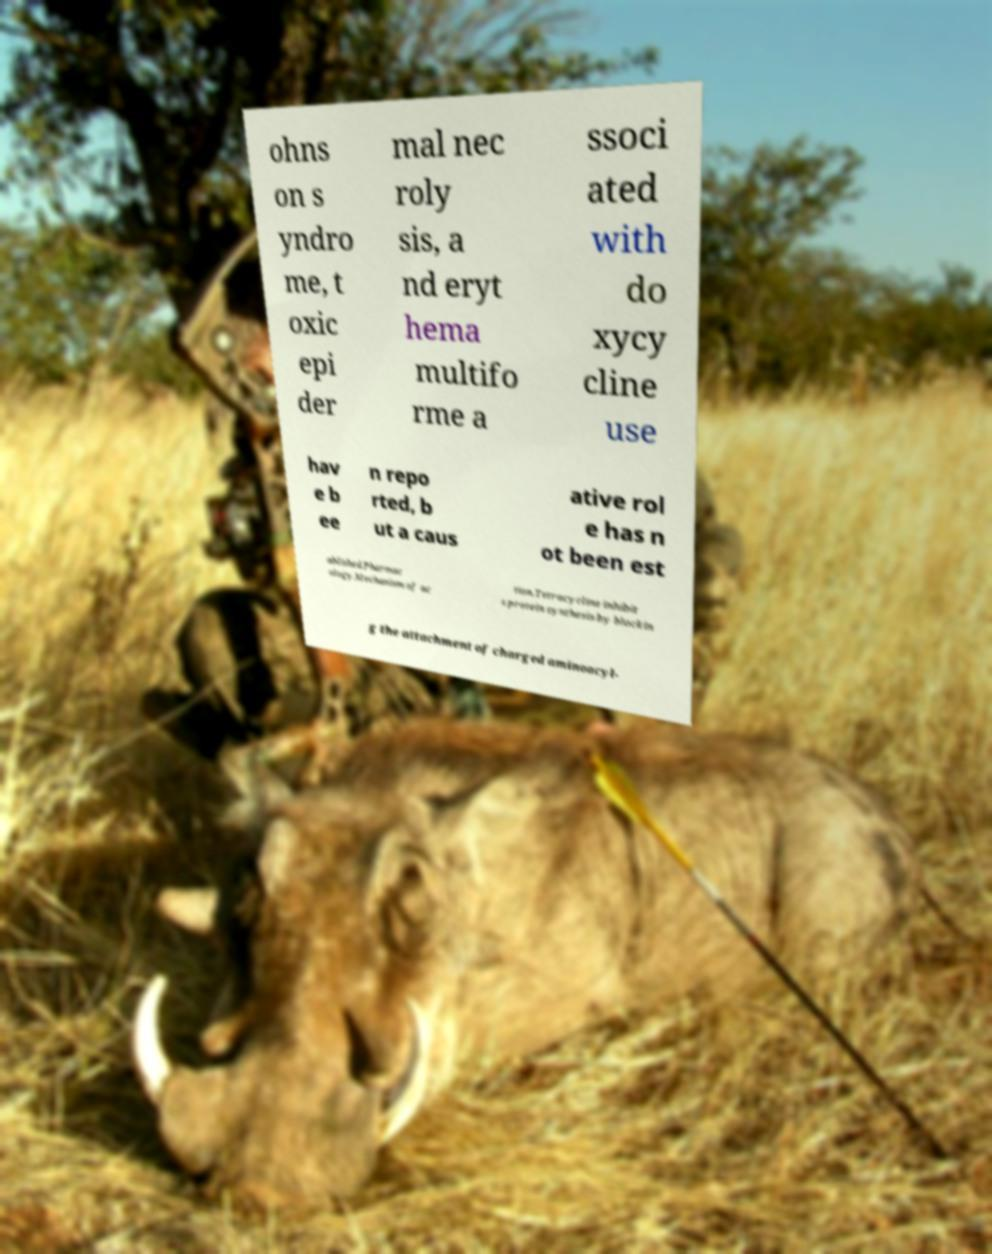Could you extract and type out the text from this image? ohns on s yndro me, t oxic epi der mal nec roly sis, a nd eryt hema multifo rme a ssoci ated with do xycy cline use hav e b ee n repo rted, b ut a caus ative rol e has n ot been est ablished.Pharmac ology.Mechanism of ac tion.Tetracycline inhibit s protein synthesis by blockin g the attachment of charged aminoacyl- 